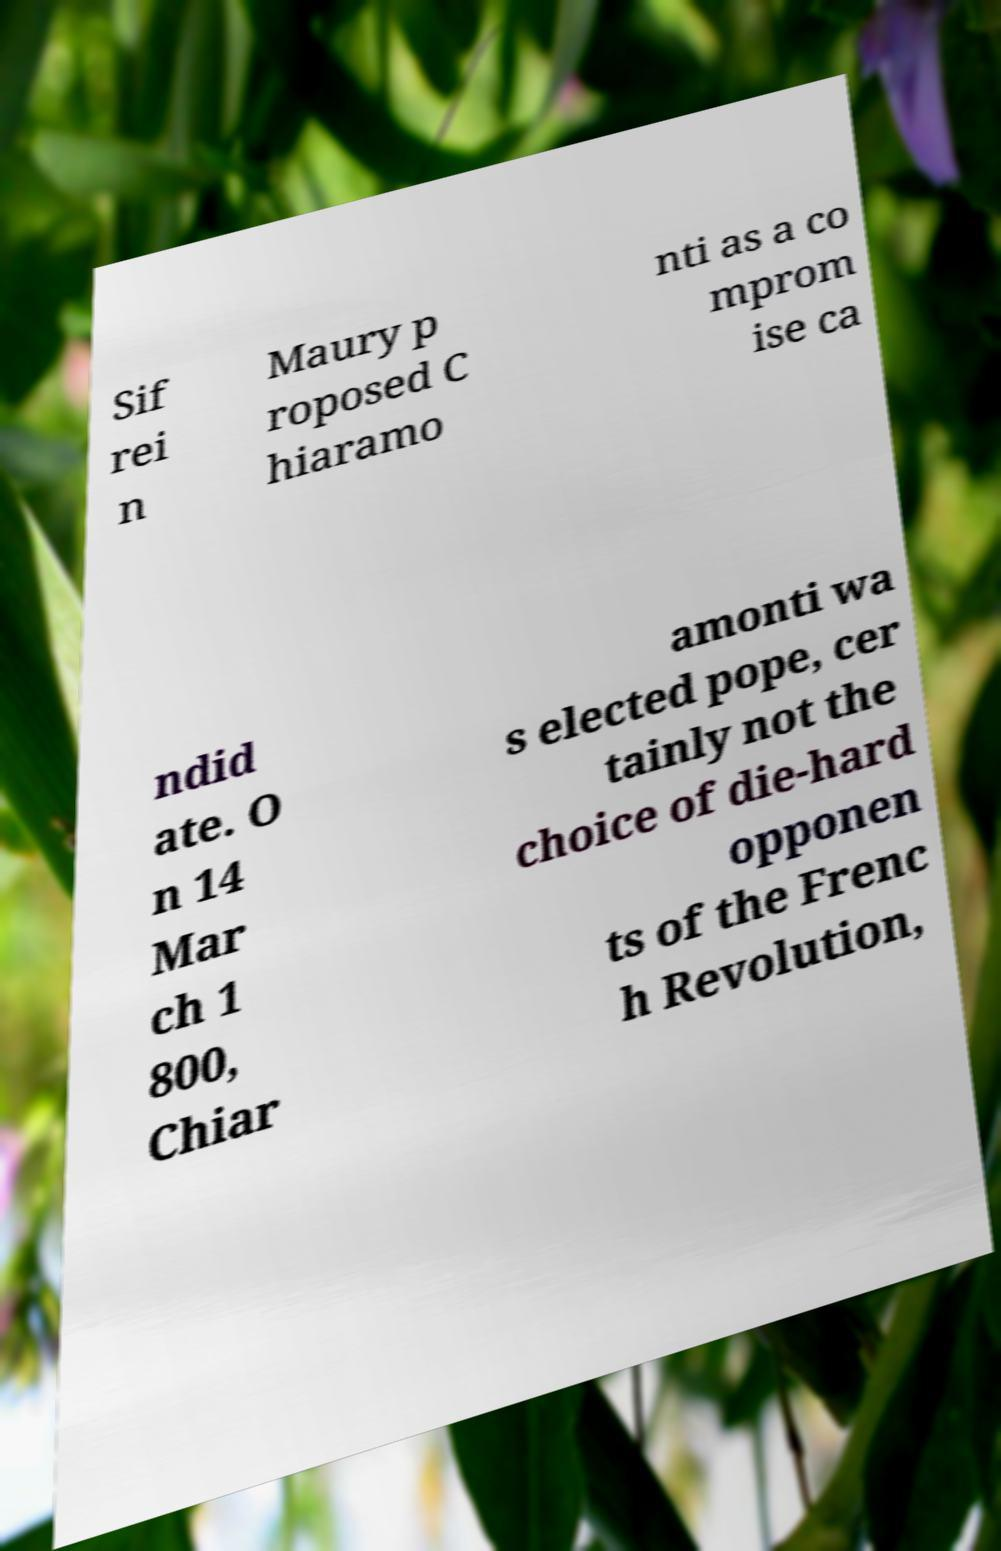I need the written content from this picture converted into text. Can you do that? Sif rei n Maury p roposed C hiaramo nti as a co mprom ise ca ndid ate. O n 14 Mar ch 1 800, Chiar amonti wa s elected pope, cer tainly not the choice of die-hard opponen ts of the Frenc h Revolution, 